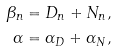<formula> <loc_0><loc_0><loc_500><loc_500>\beta _ { n } & = D _ { n } + N _ { n } , \\ \alpha & = \alpha _ { D } + \alpha _ { N } ,</formula> 